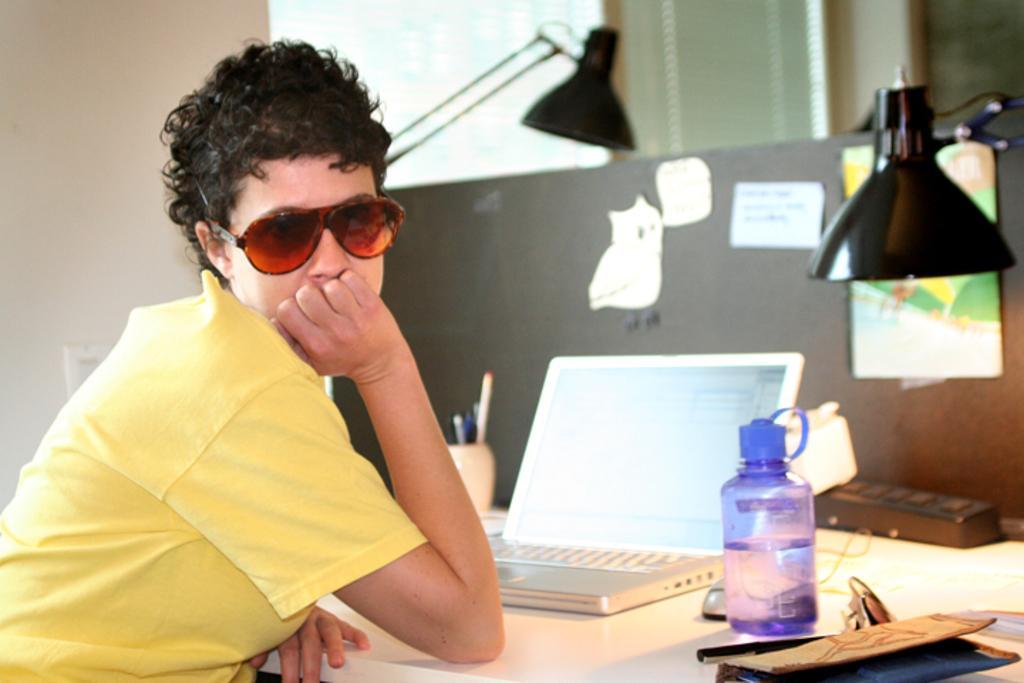Can you describe this image briefly? There is a woman sitting beside the table. There is a laptop on the table. Beside the laptop there is a water bottle, and there is mouse beside the water bottle, there is pen and the book on the table and there is a switch board on the table. There is a lamp on the table, and there is another lamp and holder. In the background there is a wall and switch board and a window and a curtain. There is a bulletin board on the table and a pen holder and some pens and pencils inside a holder. 